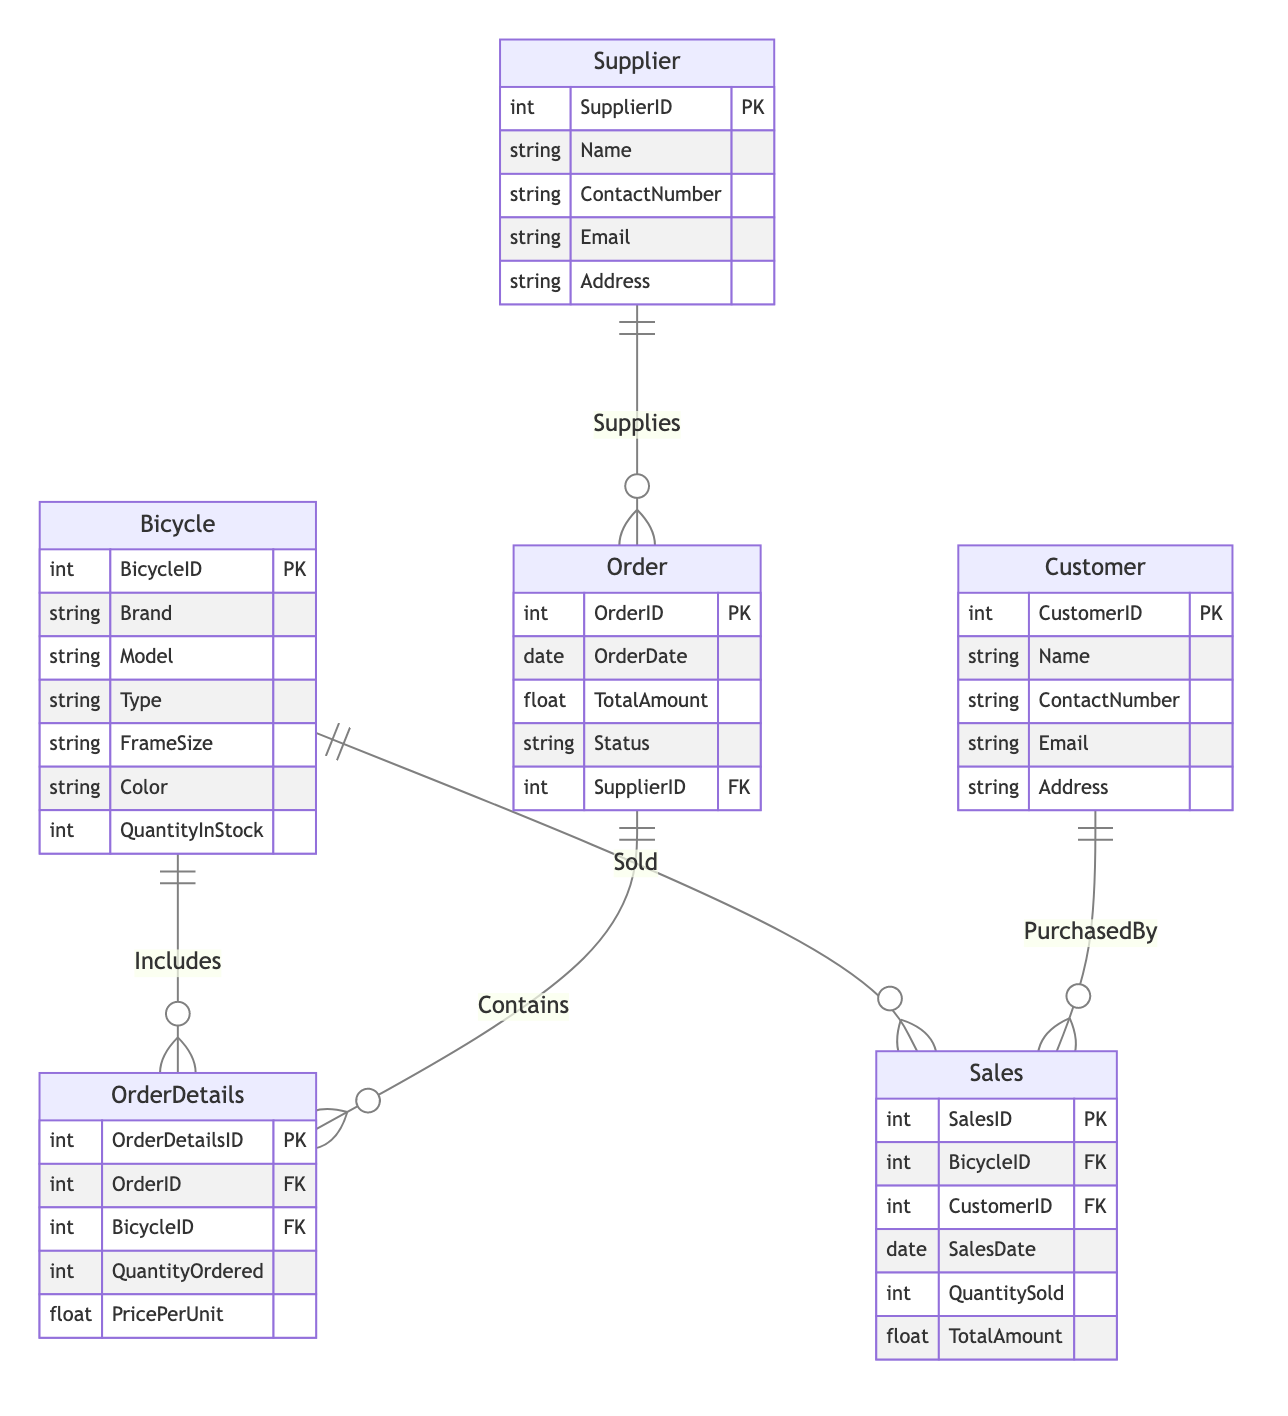What's the primary key of the Bicycle entity? The primary key of the Bicycle entity is BicycleID. This is indicated in the diagram by the notation PK next to the attribute name BicycleID.
Answer: BicycleID How many attributes does the Supplier entity have? Counting the attributes listed under the Supplier entity in the diagram, there are five attributes: SupplierID, Name, ContactNumber, Email, and Address.
Answer: Five What relationship exists between Supplier and Order? The relationship between Supplier and Order is labeled as "Supplies," which indicates that one supplier can supply many orders. This is shown in the diagram with a "one to many" notation.
Answer: Supplies What does the OrderDetails table represent in relation to the Order entity? The OrderDetails table contains detailed information about each order, including which bicycles are part of the order and the quantity of each. This relationship is labeled as "Contains."
Answer: Contains How many foreign keys are present in the Sales entity? The Sales entity has two foreign keys: BicycleID and CustomerID, which refer to the Bicycle and Customer entities, respectively. This is evident from the notation FK next to each foreign key attribute in the Sales entity.
Answer: Two Which entity is linked to the Sales entity through the PurchasedBy relationship? The Customer entity is linked to the Sales entity through the PurchasedBy relationship, indicating that one customer can make several sales. This relationship is depicted in the diagram and specifies the direction of data flow.
Answer: Customer What is the maximum number of bicycles included in an order according to the diagram? According to the diagram, the maximum number of bicycles that can be included in an order is not explicitly defined. However, since the OrderDetails entity can have multiple entries for various bicycles linked to a single order (one to many), it implies that there is no hard limit indicated.
Answer: Not specified What does the relationship "Sold" signify in the context of the Bicycle entity? The "Sold" relationship signifies that each bicycle can be sold multiple times to different customers, indicating a one-to-many relationship. This shows that one bicycle can belong to many sales records.
Answer: Sold Which entity would be queried to find out customer contact information? The Customer entity would be queried to find customer contact information, as it includes attributes for Name, ContactNumber, Email, and Address specifically related to customers.
Answer: Customer 